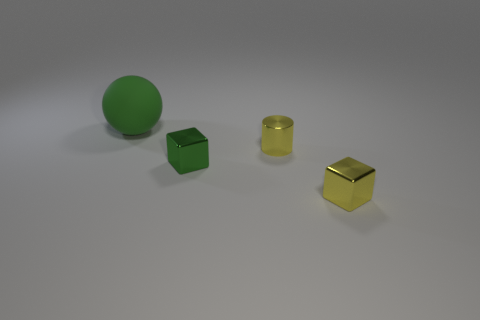Is there anything else that has the same material as the big thing?
Your answer should be very brief. No. Is there a blue object that has the same material as the green ball?
Provide a succinct answer. No. How many objects are behind the tiny green cube and in front of the large rubber object?
Make the answer very short. 1. Are there fewer small green metal blocks in front of the yellow metallic block than yellow cylinders to the right of the green matte object?
Your answer should be very brief. Yes. Is the big rubber object the same shape as the small green metal thing?
Keep it short and to the point. No. What number of other things are there of the same size as the green block?
Make the answer very short. 2. What number of things are green things in front of the sphere or blocks that are in front of the tiny green thing?
Offer a very short reply. 2. How many other small shiny objects are the same shape as the small green object?
Your response must be concise. 1. The object that is both behind the small green shiny object and in front of the green matte object is made of what material?
Offer a terse response. Metal. There is a ball; what number of yellow cubes are right of it?
Provide a short and direct response. 1. 